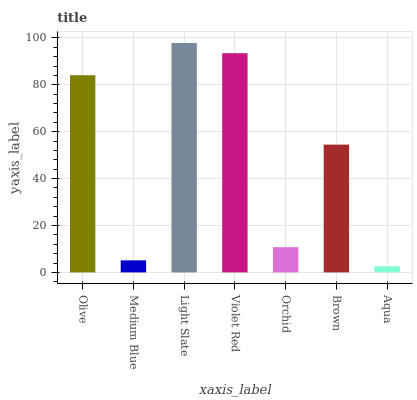Is Medium Blue the minimum?
Answer yes or no. No. Is Medium Blue the maximum?
Answer yes or no. No. Is Olive greater than Medium Blue?
Answer yes or no. Yes. Is Medium Blue less than Olive?
Answer yes or no. Yes. Is Medium Blue greater than Olive?
Answer yes or no. No. Is Olive less than Medium Blue?
Answer yes or no. No. Is Brown the high median?
Answer yes or no. Yes. Is Brown the low median?
Answer yes or no. Yes. Is Violet Red the high median?
Answer yes or no. No. Is Violet Red the low median?
Answer yes or no. No. 